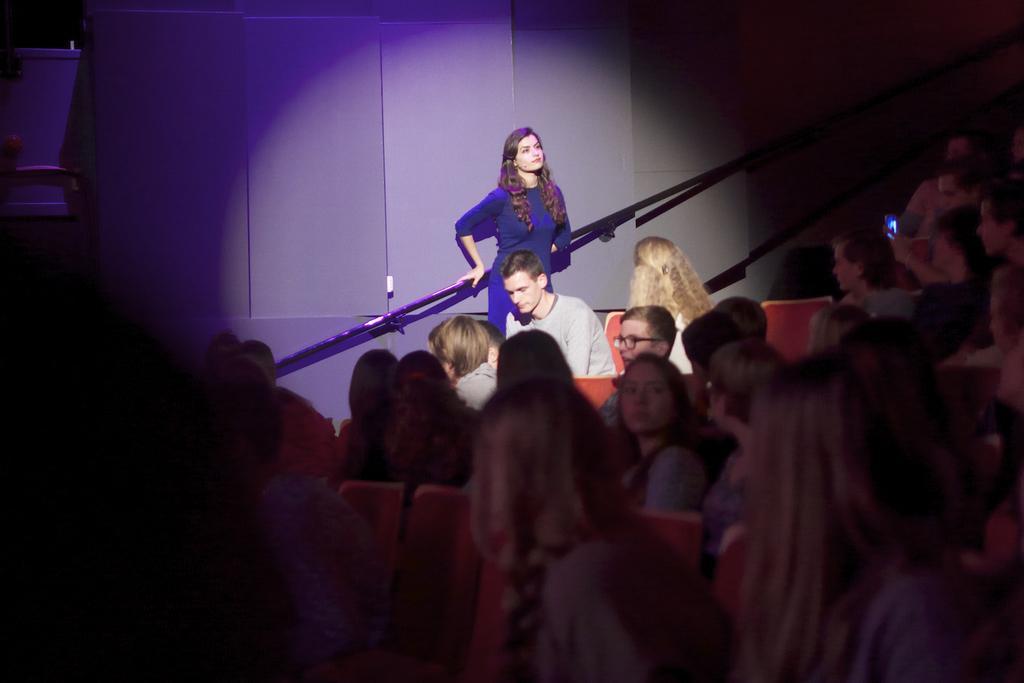Can you describe this image briefly? In this image there are group of people sitting on the chairs, and in the background there is a focus light on the person who is standing. 